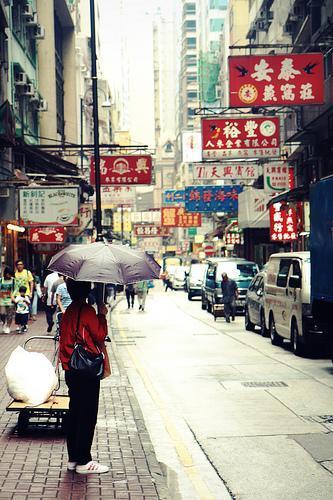How many umbrellas are there?
Give a very brief answer. 1. 